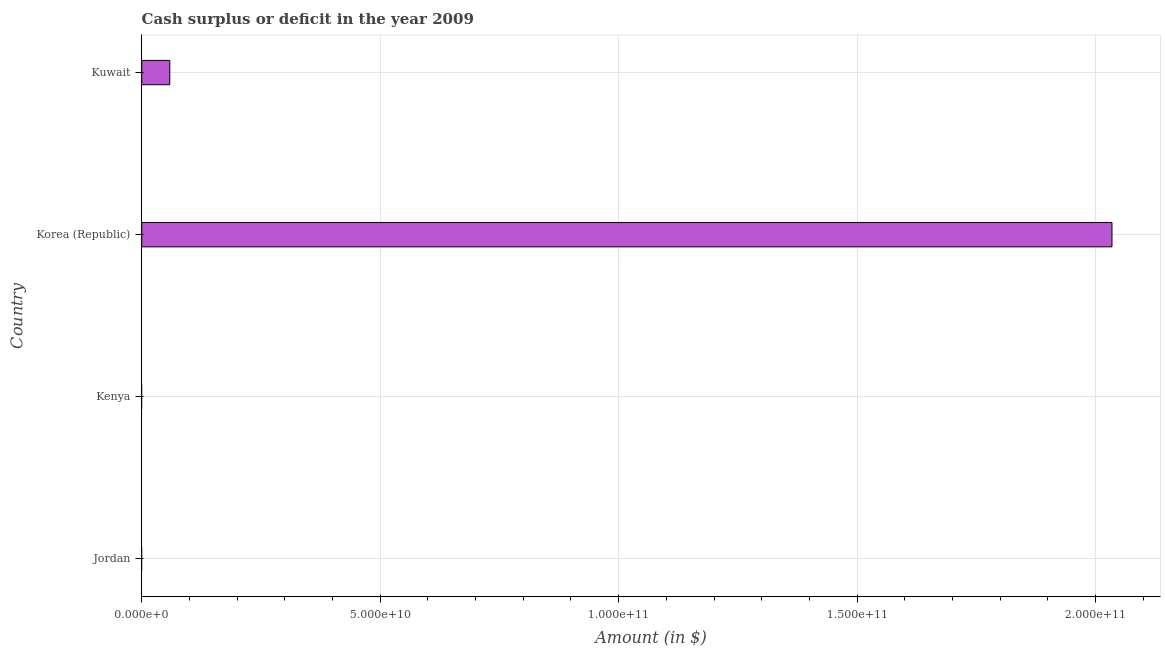Does the graph contain any zero values?
Make the answer very short. Yes. Does the graph contain grids?
Offer a terse response. Yes. What is the title of the graph?
Keep it short and to the point. Cash surplus or deficit in the year 2009. What is the label or title of the X-axis?
Ensure brevity in your answer.  Amount (in $). Across all countries, what is the maximum cash surplus or deficit?
Make the answer very short. 2.03e+11. Across all countries, what is the minimum cash surplus or deficit?
Your answer should be very brief. 0. In which country was the cash surplus or deficit maximum?
Your answer should be compact. Korea (Republic). What is the sum of the cash surplus or deficit?
Offer a terse response. 2.09e+11. What is the difference between the cash surplus or deficit in Korea (Republic) and Kuwait?
Ensure brevity in your answer.  1.98e+11. What is the average cash surplus or deficit per country?
Provide a short and direct response. 5.23e+1. What is the median cash surplus or deficit?
Your response must be concise. 2.94e+09. In how many countries, is the cash surplus or deficit greater than 110000000000 $?
Provide a short and direct response. 1. What is the ratio of the cash surplus or deficit in Korea (Republic) to that in Kuwait?
Your answer should be very brief. 34.59. Is the difference between the cash surplus or deficit in Korea (Republic) and Kuwait greater than the difference between any two countries?
Offer a very short reply. No. What is the difference between the highest and the lowest cash surplus or deficit?
Your response must be concise. 2.03e+11. How many bars are there?
Ensure brevity in your answer.  2. Are all the bars in the graph horizontal?
Make the answer very short. Yes. What is the difference between two consecutive major ticks on the X-axis?
Provide a short and direct response. 5.00e+1. What is the Amount (in $) in Jordan?
Provide a succinct answer. 0. What is the Amount (in $) of Kenya?
Make the answer very short. 0. What is the Amount (in $) of Korea (Republic)?
Your answer should be compact. 2.03e+11. What is the Amount (in $) in Kuwait?
Ensure brevity in your answer.  5.88e+09. What is the difference between the Amount (in $) in Korea (Republic) and Kuwait?
Provide a short and direct response. 1.98e+11. What is the ratio of the Amount (in $) in Korea (Republic) to that in Kuwait?
Your response must be concise. 34.59. 